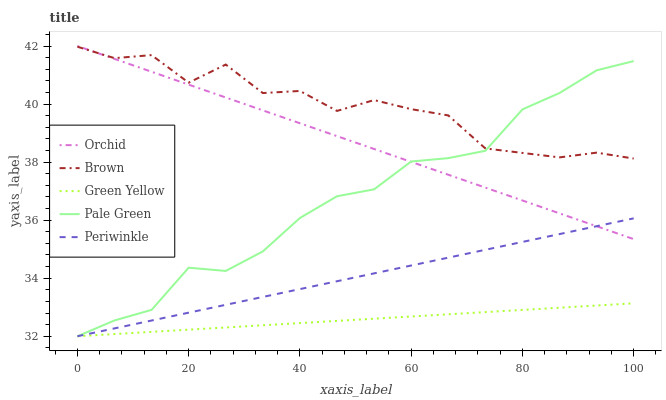Does Green Yellow have the minimum area under the curve?
Answer yes or no. Yes. Does Brown have the maximum area under the curve?
Answer yes or no. Yes. Does Pale Green have the minimum area under the curve?
Answer yes or no. No. Does Pale Green have the maximum area under the curve?
Answer yes or no. No. Is Green Yellow the smoothest?
Answer yes or no. Yes. Is Brown the roughest?
Answer yes or no. Yes. Is Pale Green the smoothest?
Answer yes or no. No. Is Pale Green the roughest?
Answer yes or no. No. Does Pale Green have the lowest value?
Answer yes or no. Yes. Does Orchid have the lowest value?
Answer yes or no. No. Does Orchid have the highest value?
Answer yes or no. Yes. Does Pale Green have the highest value?
Answer yes or no. No. Is Periwinkle less than Brown?
Answer yes or no. Yes. Is Brown greater than Periwinkle?
Answer yes or no. Yes. Does Orchid intersect Brown?
Answer yes or no. Yes. Is Orchid less than Brown?
Answer yes or no. No. Is Orchid greater than Brown?
Answer yes or no. No. Does Periwinkle intersect Brown?
Answer yes or no. No. 